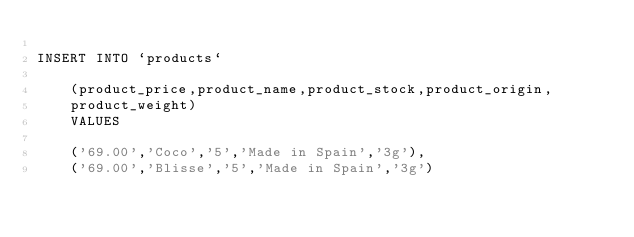Convert code to text. <code><loc_0><loc_0><loc_500><loc_500><_SQL_>
INSERT INTO `products` 

    (product_price,product_name,product_stock,product_origin,
    product_weight)
    VALUES
    
    ('69.00','Coco','5','Made in Spain','3g'),
    ('69.00','Blisse','5','Made in Spain','3g')
    
    </code> 